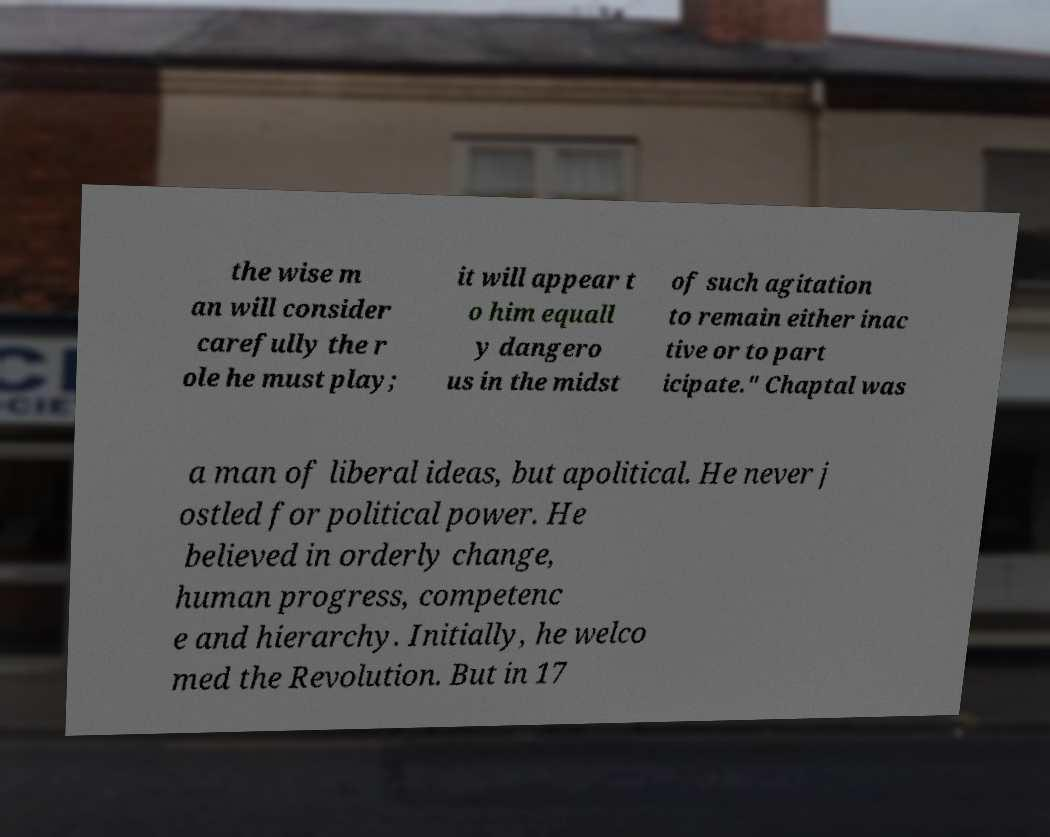I need the written content from this picture converted into text. Can you do that? the wise m an will consider carefully the r ole he must play; it will appear t o him equall y dangero us in the midst of such agitation to remain either inac tive or to part icipate." Chaptal was a man of liberal ideas, but apolitical. He never j ostled for political power. He believed in orderly change, human progress, competenc e and hierarchy. Initially, he welco med the Revolution. But in 17 